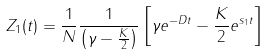Convert formula to latex. <formula><loc_0><loc_0><loc_500><loc_500>Z _ { 1 } ( t ) = \frac { 1 } { N } \frac { 1 } { { \left ( \gamma - \frac { K } { 2 } \right ) } } \left [ \gamma e ^ { - D t } - \frac { K } { 2 } e ^ { s _ { 1 } t } \right ]</formula> 